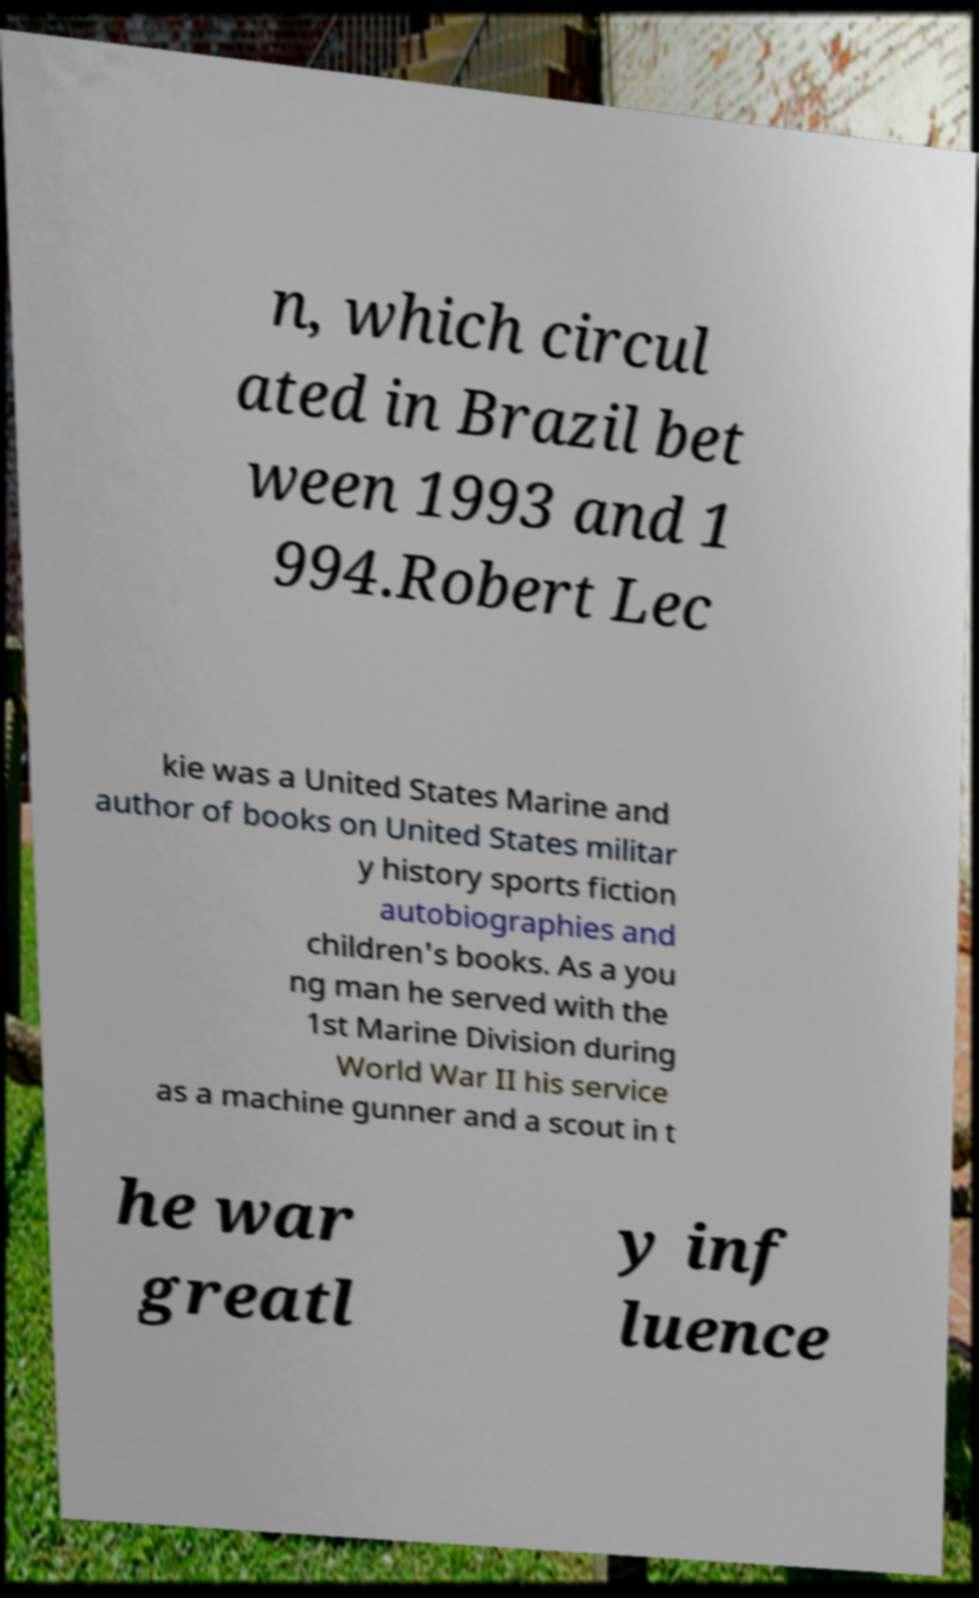Could you extract and type out the text from this image? n, which circul ated in Brazil bet ween 1993 and 1 994.Robert Lec kie was a United States Marine and author of books on United States militar y history sports fiction autobiographies and children's books. As a you ng man he served with the 1st Marine Division during World War II his service as a machine gunner and a scout in t he war greatl y inf luence 